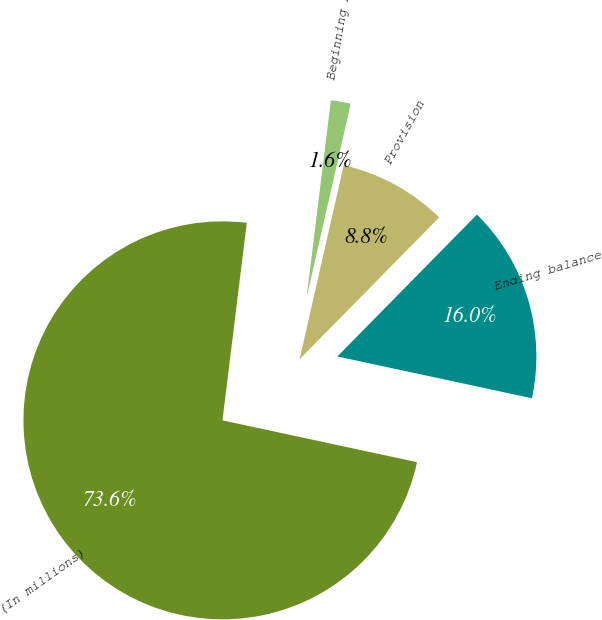Convert chart. <chart><loc_0><loc_0><loc_500><loc_500><pie_chart><fcel>(In millions)<fcel>Beginning balance<fcel>Provision<fcel>Ending balance<nl><fcel>73.58%<fcel>1.61%<fcel>8.81%<fcel>16.0%<nl></chart> 